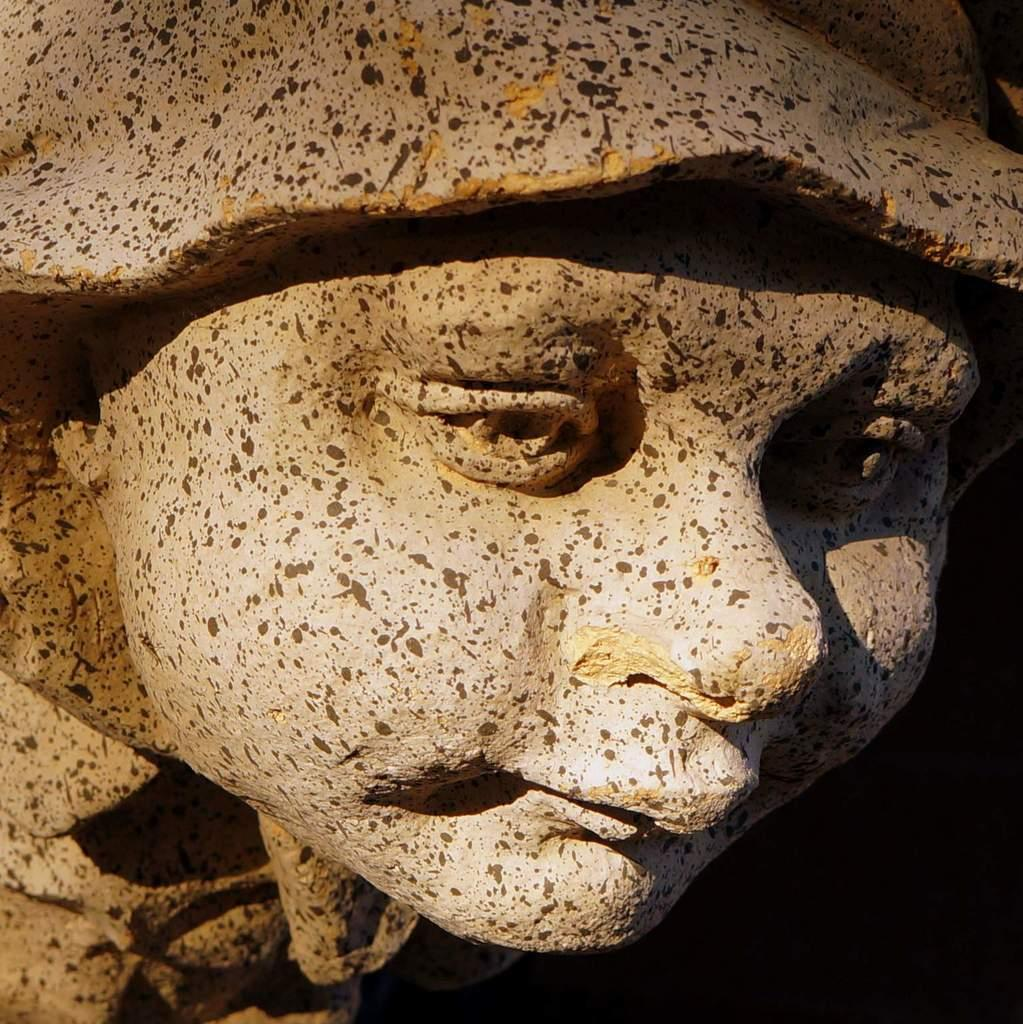What is the main subject of the image? There is a sculpture in the image. Can you describe the appearance of the sculpture? The sculpture has gray colored marks. What can be seen in the background of the image? The background of the image is dark in color. What type of spy activity is happening in the image? There is no indication of any spy activity in the image; it features a sculpture with gray colored marks against a dark background. What type of leaf can be seen in the image? There are no leaves present in the image. 